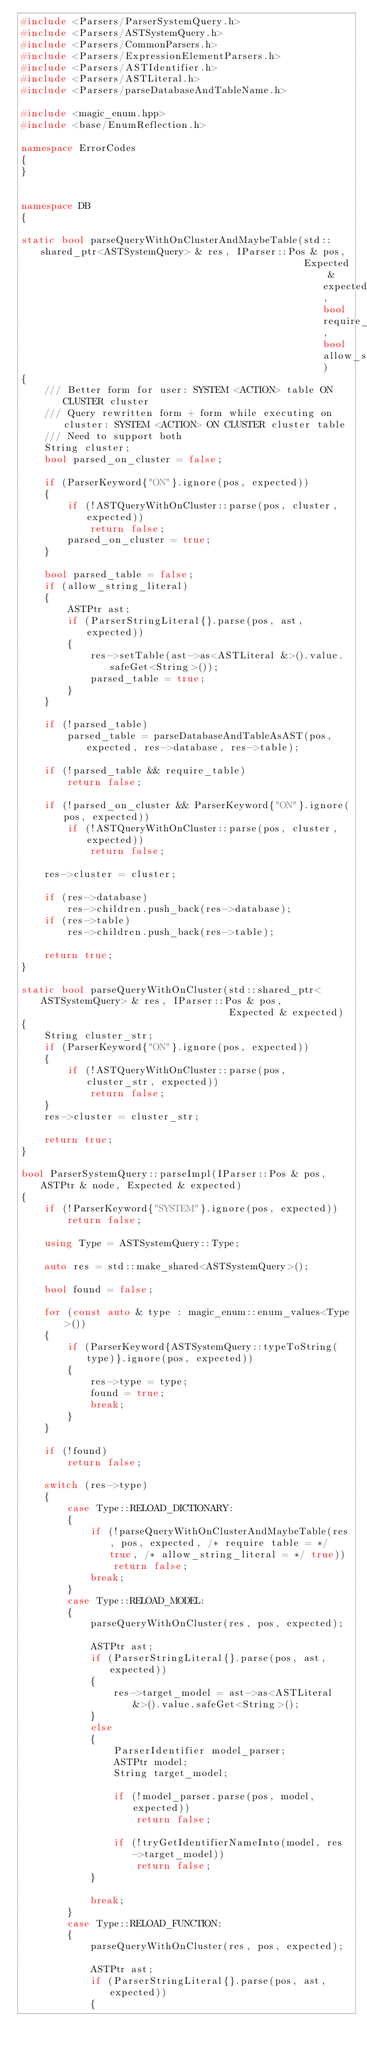<code> <loc_0><loc_0><loc_500><loc_500><_C++_>#include <Parsers/ParserSystemQuery.h>
#include <Parsers/ASTSystemQuery.h>
#include <Parsers/CommonParsers.h>
#include <Parsers/ExpressionElementParsers.h>
#include <Parsers/ASTIdentifier.h>
#include <Parsers/ASTLiteral.h>
#include <Parsers/parseDatabaseAndTableName.h>

#include <magic_enum.hpp>
#include <base/EnumReflection.h>

namespace ErrorCodes
{
}


namespace DB
{

static bool parseQueryWithOnClusterAndMaybeTable(std::shared_ptr<ASTSystemQuery> & res, IParser::Pos & pos,
                                                 Expected & expected, bool require_table, bool allow_string_literal)
{
    /// Better form for user: SYSTEM <ACTION> table ON CLUSTER cluster
    /// Query rewritten form + form while executing on cluster: SYSTEM <ACTION> ON CLUSTER cluster table
    /// Need to support both
    String cluster;
    bool parsed_on_cluster = false;

    if (ParserKeyword{"ON"}.ignore(pos, expected))
    {
        if (!ASTQueryWithOnCluster::parse(pos, cluster, expected))
            return false;
        parsed_on_cluster = true;
    }

    bool parsed_table = false;
    if (allow_string_literal)
    {
        ASTPtr ast;
        if (ParserStringLiteral{}.parse(pos, ast, expected))
        {
            res->setTable(ast->as<ASTLiteral &>().value.safeGet<String>());
            parsed_table = true;
        }
    }

    if (!parsed_table)
        parsed_table = parseDatabaseAndTableAsAST(pos, expected, res->database, res->table);

    if (!parsed_table && require_table)
        return false;

    if (!parsed_on_cluster && ParserKeyword{"ON"}.ignore(pos, expected))
        if (!ASTQueryWithOnCluster::parse(pos, cluster, expected))
            return false;

    res->cluster = cluster;

    if (res->database)
        res->children.push_back(res->database);
    if (res->table)
        res->children.push_back(res->table);

    return true;
}

static bool parseQueryWithOnCluster(std::shared_ptr<ASTSystemQuery> & res, IParser::Pos & pos,
                                    Expected & expected)
{
    String cluster_str;
    if (ParserKeyword{"ON"}.ignore(pos, expected))
    {
        if (!ASTQueryWithOnCluster::parse(pos, cluster_str, expected))
            return false;
    }
    res->cluster = cluster_str;

    return true;
}

bool ParserSystemQuery::parseImpl(IParser::Pos & pos, ASTPtr & node, Expected & expected)
{
    if (!ParserKeyword{"SYSTEM"}.ignore(pos, expected))
        return false;

    using Type = ASTSystemQuery::Type;

    auto res = std::make_shared<ASTSystemQuery>();

    bool found = false;

    for (const auto & type : magic_enum::enum_values<Type>())
    {
        if (ParserKeyword{ASTSystemQuery::typeToString(type)}.ignore(pos, expected))
        {
            res->type = type;
            found = true;
            break;
        }
    }

    if (!found)
        return false;

    switch (res->type)
    {
        case Type::RELOAD_DICTIONARY:
        {
            if (!parseQueryWithOnClusterAndMaybeTable(res, pos, expected, /* require table = */ true, /* allow_string_literal = */ true))
                return false;
            break;
        }
        case Type::RELOAD_MODEL:
        {
            parseQueryWithOnCluster(res, pos, expected);

            ASTPtr ast;
            if (ParserStringLiteral{}.parse(pos, ast, expected))
            {
                res->target_model = ast->as<ASTLiteral &>().value.safeGet<String>();
            }
            else
            {
                ParserIdentifier model_parser;
                ASTPtr model;
                String target_model;

                if (!model_parser.parse(pos, model, expected))
                    return false;

                if (!tryGetIdentifierNameInto(model, res->target_model))
                    return false;
            }

            break;
        }
        case Type::RELOAD_FUNCTION:
        {
            parseQueryWithOnCluster(res, pos, expected);

            ASTPtr ast;
            if (ParserStringLiteral{}.parse(pos, ast, expected))
            {</code> 